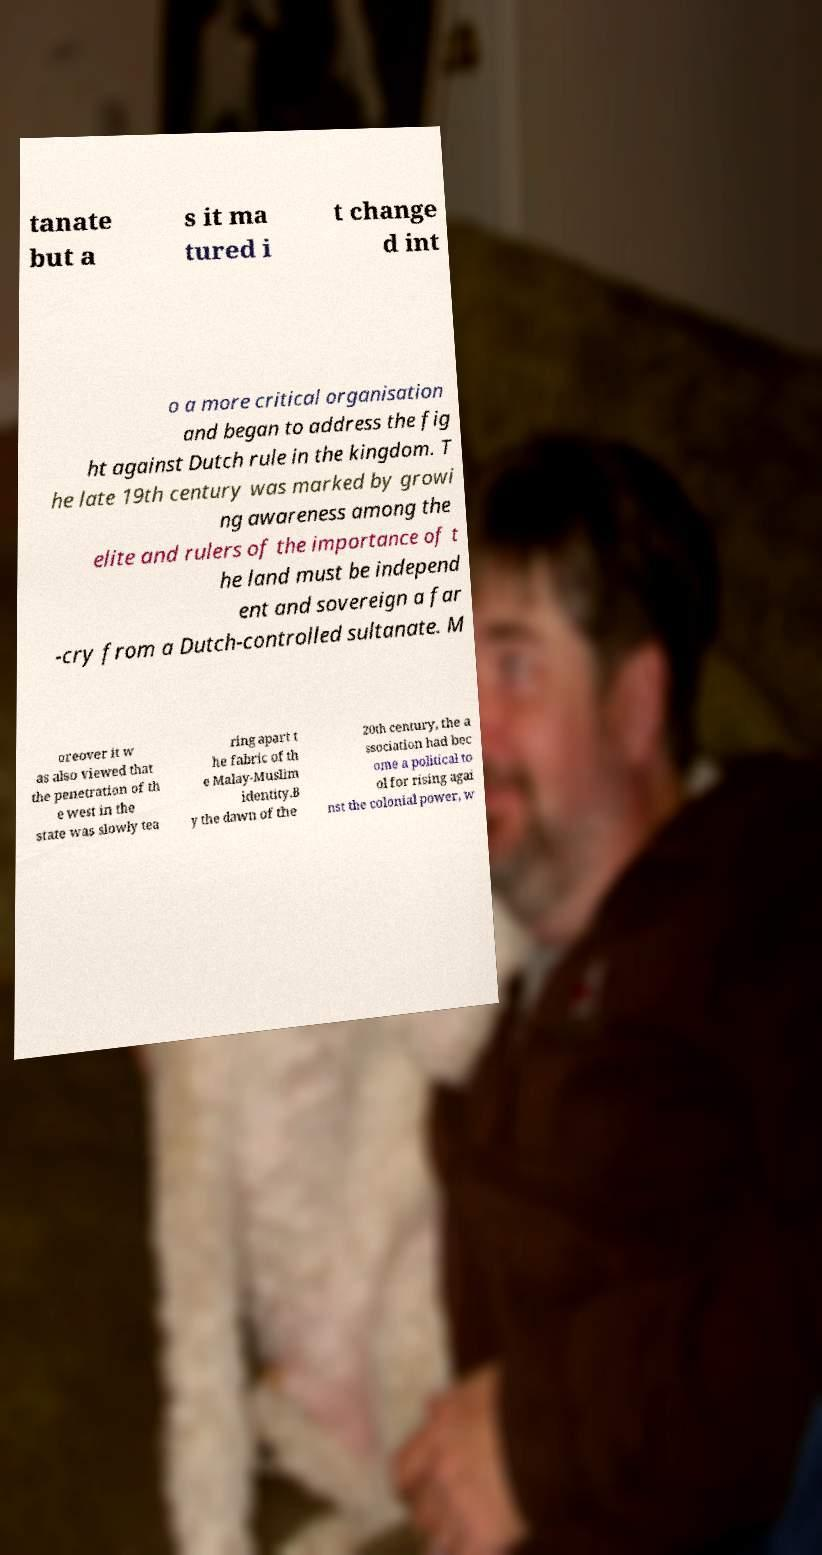What messages or text are displayed in this image? I need them in a readable, typed format. tanate but a s it ma tured i t change d int o a more critical organisation and began to address the fig ht against Dutch rule in the kingdom. T he late 19th century was marked by growi ng awareness among the elite and rulers of the importance of t he land must be independ ent and sovereign a far -cry from a Dutch-controlled sultanate. M oreover it w as also viewed that the penetration of th e west in the state was slowly tea ring apart t he fabric of th e Malay-Muslim identity.B y the dawn of the 20th century, the a ssociation had bec ome a political to ol for rising agai nst the colonial power, w 